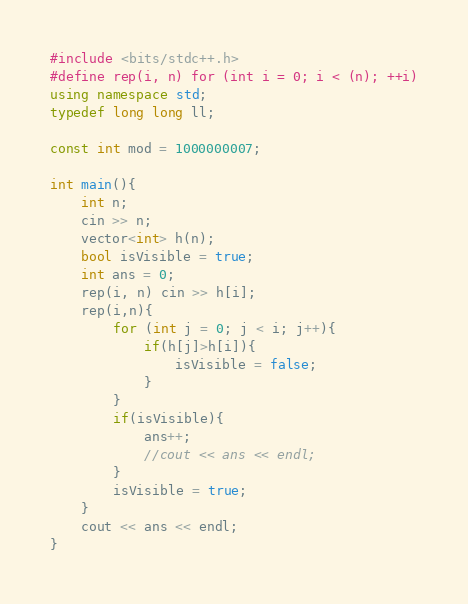Convert code to text. <code><loc_0><loc_0><loc_500><loc_500><_C++_>#include <bits/stdc++.h>
#define rep(i, n) for (int i = 0; i < (n); ++i)
using namespace std;
typedef long long ll;

const int mod = 1000000007;

int main(){
    int n;
    cin >> n;
    vector<int> h(n);
    bool isVisible = true;
    int ans = 0;
    rep(i, n) cin >> h[i];
    rep(i,n){
        for (int j = 0; j < i; j++){
            if(h[j]>h[i]){
                isVisible = false;
            }
        }
        if(isVisible){
            ans++;
            //cout << ans << endl;
        }
        isVisible = true;
    }
    cout << ans << endl;
}</code> 